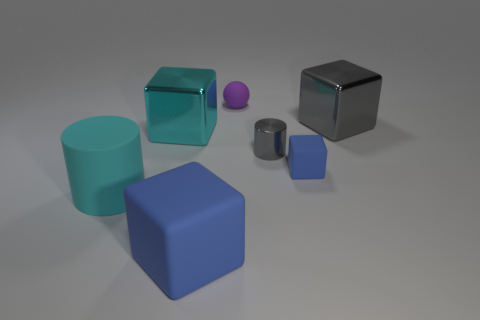Subtract all gray metallic blocks. How many blocks are left? 3 Subtract all blue blocks. How many were subtracted if there are1blue blocks left? 1 Subtract all blue blocks. How many blocks are left? 2 Subtract 2 cylinders. How many cylinders are left? 0 Subtract all brown balls. Subtract all green cylinders. How many balls are left? 1 Subtract all brown balls. How many blue cylinders are left? 0 Subtract all big brown matte blocks. Subtract all cyan metal objects. How many objects are left? 6 Add 4 big cyan rubber objects. How many big cyan rubber objects are left? 5 Add 1 large cyan metal blocks. How many large cyan metal blocks exist? 2 Add 3 purple objects. How many objects exist? 10 